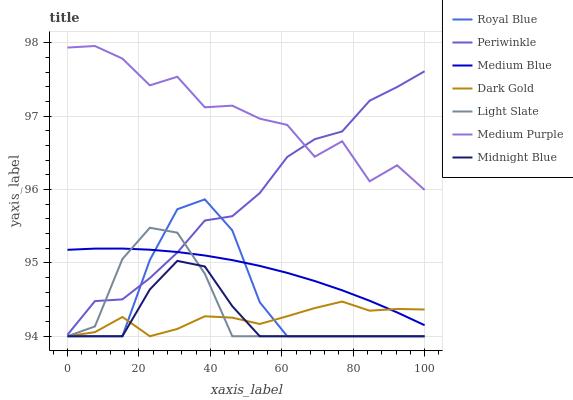Does Midnight Blue have the minimum area under the curve?
Answer yes or no. Yes. Does Medium Purple have the maximum area under the curve?
Answer yes or no. Yes. Does Dark Gold have the minimum area under the curve?
Answer yes or no. No. Does Dark Gold have the maximum area under the curve?
Answer yes or no. No. Is Medium Blue the smoothest?
Answer yes or no. Yes. Is Medium Purple the roughest?
Answer yes or no. Yes. Is Dark Gold the smoothest?
Answer yes or no. No. Is Dark Gold the roughest?
Answer yes or no. No. Does Midnight Blue have the lowest value?
Answer yes or no. Yes. Does Medium Blue have the lowest value?
Answer yes or no. No. Does Medium Purple have the highest value?
Answer yes or no. Yes. Does Light Slate have the highest value?
Answer yes or no. No. Is Midnight Blue less than Medium Blue?
Answer yes or no. Yes. Is Medium Blue greater than Midnight Blue?
Answer yes or no. Yes. Does Midnight Blue intersect Dark Gold?
Answer yes or no. Yes. Is Midnight Blue less than Dark Gold?
Answer yes or no. No. Is Midnight Blue greater than Dark Gold?
Answer yes or no. No. Does Midnight Blue intersect Medium Blue?
Answer yes or no. No. 